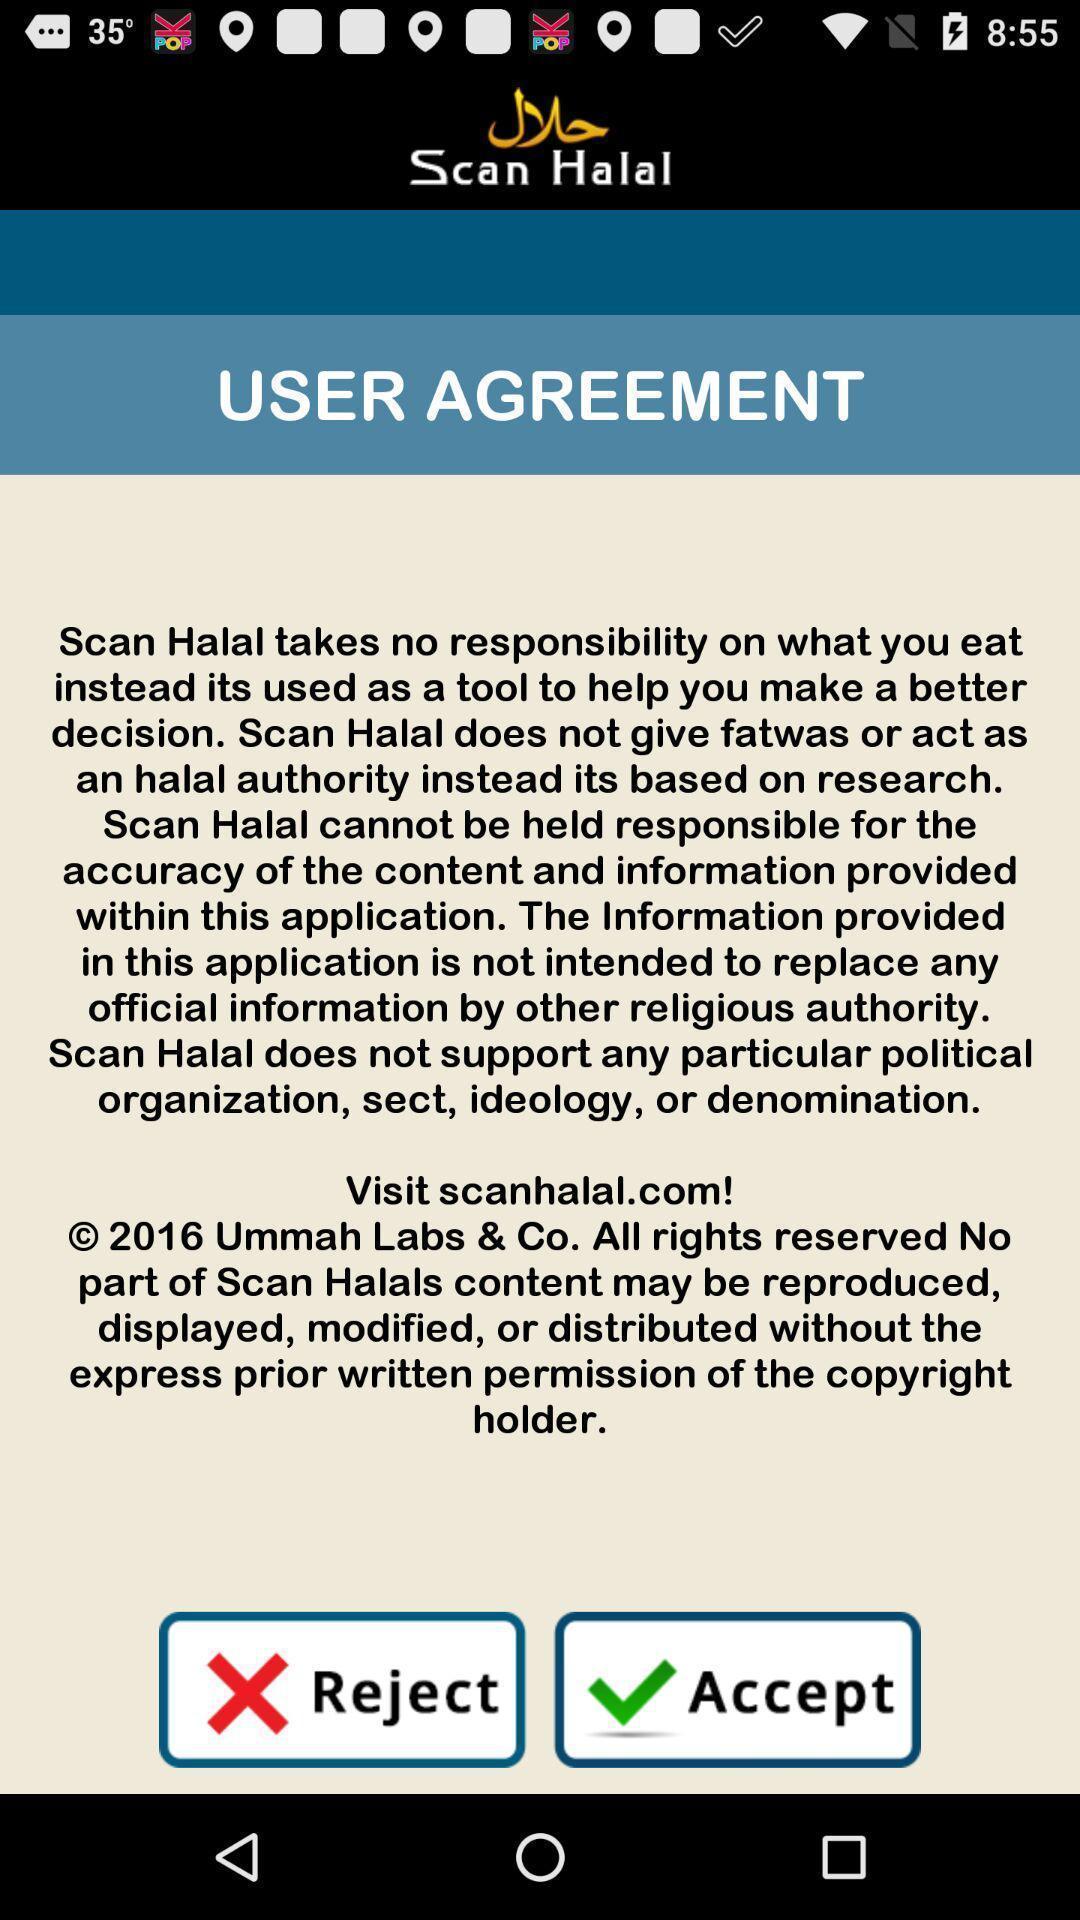Describe this image in words. User agreement screen in food app. 